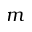Convert formula to latex. <formula><loc_0><loc_0><loc_500><loc_500>m</formula> 